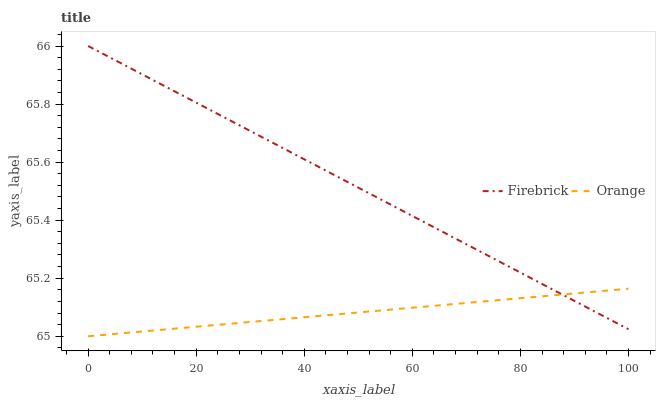Does Firebrick have the minimum area under the curve?
Answer yes or no. No. Is Firebrick the smoothest?
Answer yes or no. No. Does Firebrick have the lowest value?
Answer yes or no. No. 